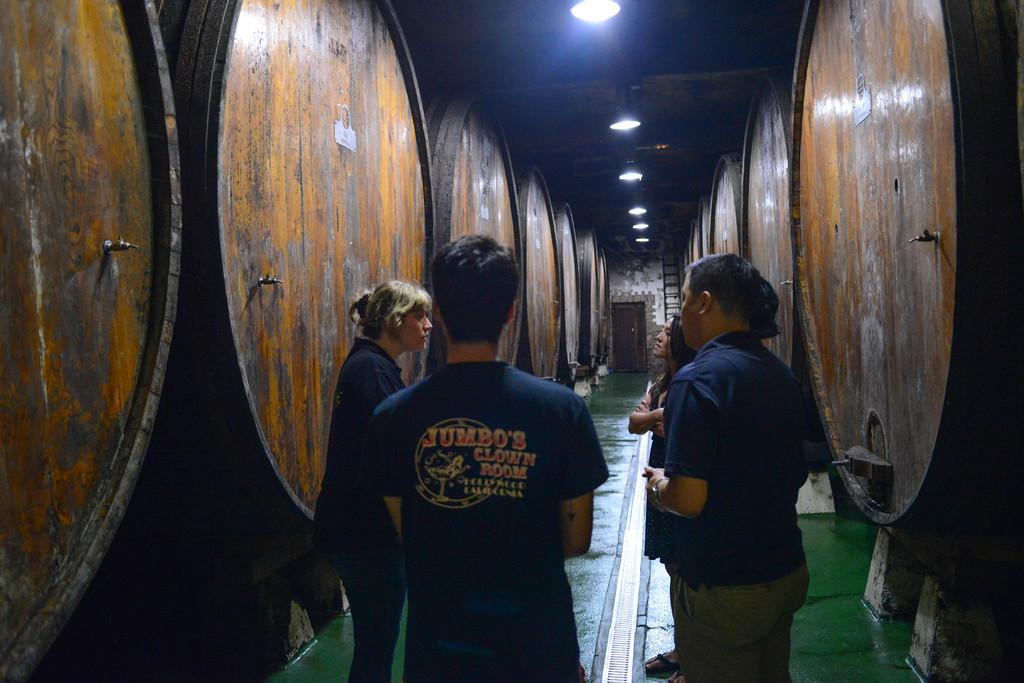How would you summarize this image in a sentence or two? At the top we can see the lights. In the background we can see the wall and it seems like a door. In this picture we can see the people standing. On either side of them we can see the objects. At the bottom we can see the floor. 